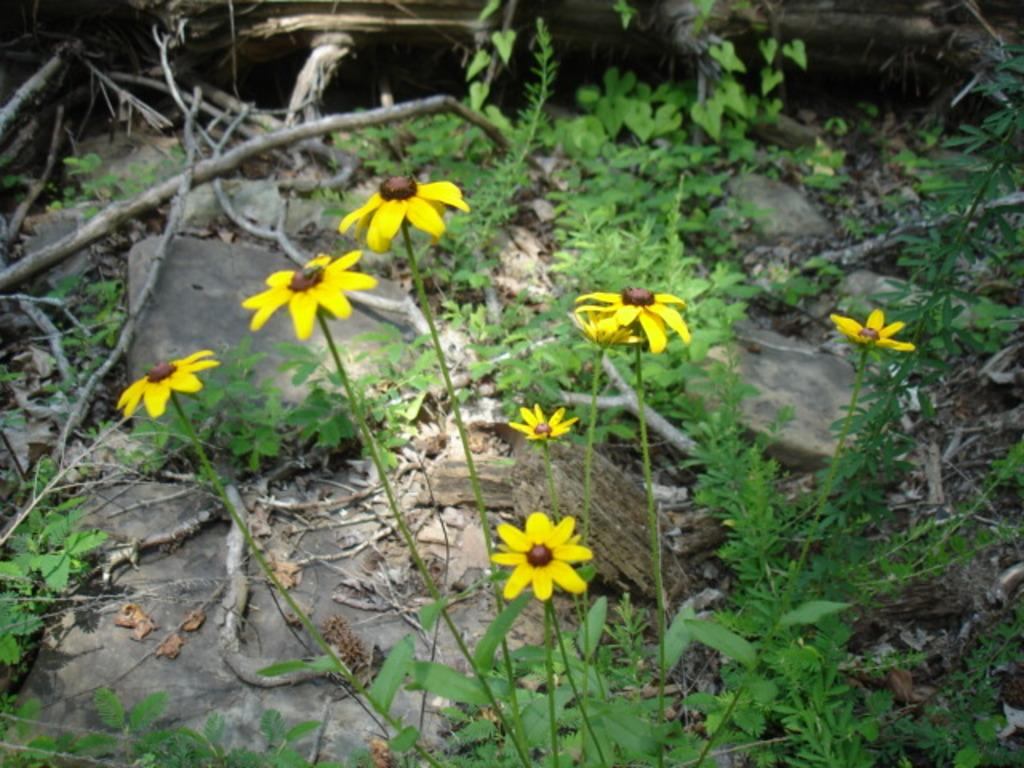What type of living organisms are in the image? The image contains plants and flowers. What color are the flowers in the image? The flowers in the image are in yellow color. What type of furniture can be seen in the image? There is no furniture present in the image; it features plants and flowers. Can you see a road in the image? There is no road present in the image; it features plants and flowers. 